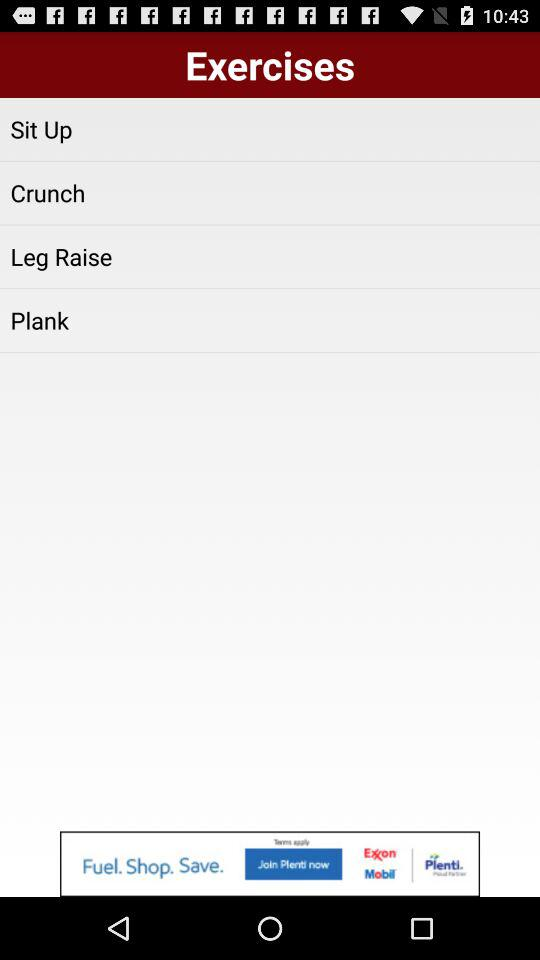What are the different types of exercises? The different types of exercises are "Sit Up", "Crunch", "Leg Raise" and "Plank". 